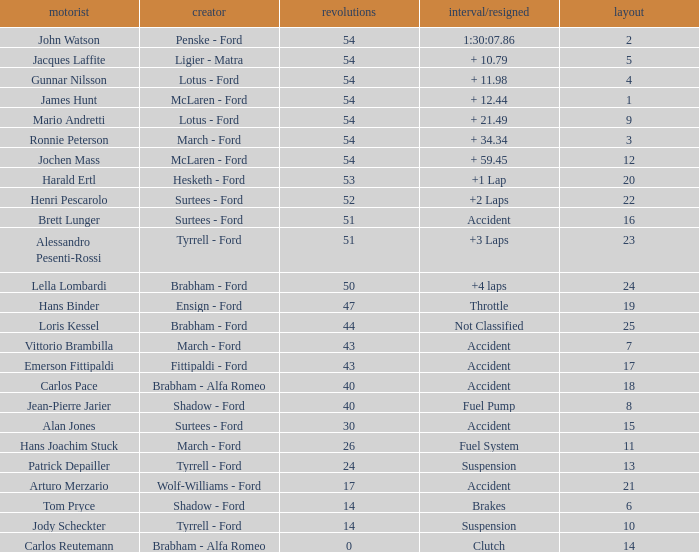What is the Time/Retired of Carlos Reutemann who was driving a brabham - Alfa Romeo? Clutch. 